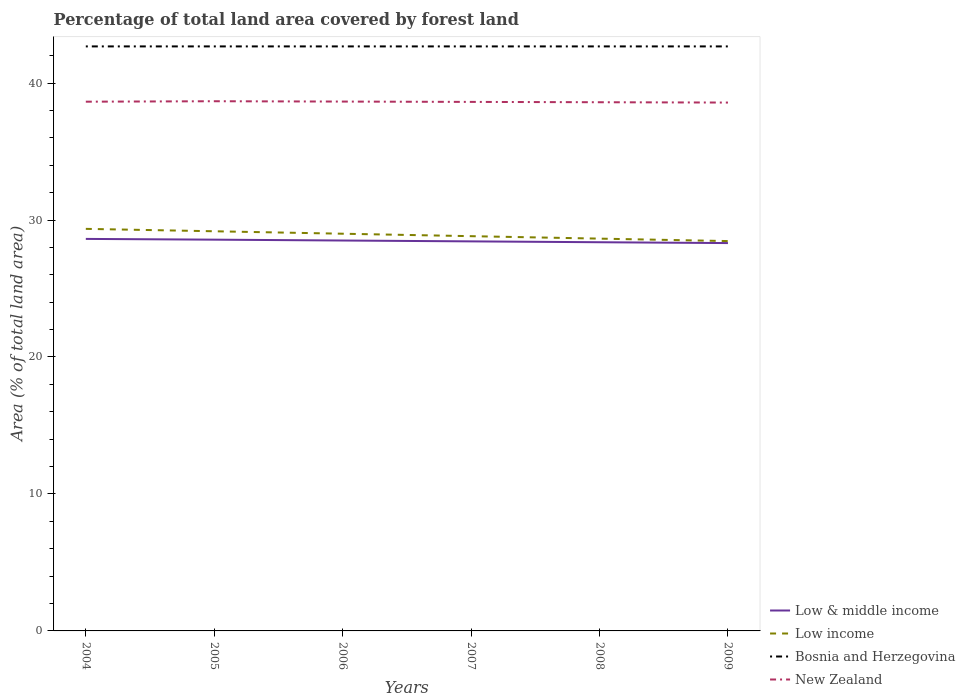How many different coloured lines are there?
Offer a terse response. 4. Is the number of lines equal to the number of legend labels?
Your answer should be very brief. Yes. Across all years, what is the maximum percentage of forest land in Low & middle income?
Ensure brevity in your answer.  28.32. In which year was the percentage of forest land in Bosnia and Herzegovina maximum?
Your response must be concise. 2004. What is the total percentage of forest land in Low & middle income in the graph?
Offer a terse response. 0.06. What is the difference between the highest and the second highest percentage of forest land in Low income?
Give a very brief answer. 0.89. How many lines are there?
Provide a succinct answer. 4. How many years are there in the graph?
Your response must be concise. 6. Are the values on the major ticks of Y-axis written in scientific E-notation?
Your answer should be very brief. No. Where does the legend appear in the graph?
Ensure brevity in your answer.  Bottom right. How many legend labels are there?
Give a very brief answer. 4. How are the legend labels stacked?
Keep it short and to the point. Vertical. What is the title of the graph?
Your answer should be very brief. Percentage of total land area covered by forest land. Does "Finland" appear as one of the legend labels in the graph?
Make the answer very short. No. What is the label or title of the Y-axis?
Provide a short and direct response. Area (% of total land area). What is the Area (% of total land area) in Low & middle income in 2004?
Your answer should be compact. 28.62. What is the Area (% of total land area) of Low income in 2004?
Your answer should be very brief. 29.35. What is the Area (% of total land area) of Bosnia and Herzegovina in 2004?
Your answer should be very brief. 42.68. What is the Area (% of total land area) in New Zealand in 2004?
Offer a very short reply. 38.64. What is the Area (% of total land area) in Low & middle income in 2005?
Keep it short and to the point. 28.57. What is the Area (% of total land area) in Low income in 2005?
Your answer should be very brief. 29.18. What is the Area (% of total land area) of Bosnia and Herzegovina in 2005?
Make the answer very short. 42.68. What is the Area (% of total land area) in New Zealand in 2005?
Offer a very short reply. 38.67. What is the Area (% of total land area) in Low & middle income in 2006?
Your response must be concise. 28.5. What is the Area (% of total land area) in Low income in 2006?
Your answer should be very brief. 29. What is the Area (% of total land area) in Bosnia and Herzegovina in 2006?
Make the answer very short. 42.68. What is the Area (% of total land area) in New Zealand in 2006?
Provide a succinct answer. 38.65. What is the Area (% of total land area) in Low & middle income in 2007?
Your response must be concise. 28.44. What is the Area (% of total land area) of Low income in 2007?
Give a very brief answer. 28.82. What is the Area (% of total land area) in Bosnia and Herzegovina in 2007?
Offer a terse response. 42.68. What is the Area (% of total land area) in New Zealand in 2007?
Offer a terse response. 38.62. What is the Area (% of total land area) in Low & middle income in 2008?
Offer a very short reply. 28.38. What is the Area (% of total land area) of Low income in 2008?
Offer a very short reply. 28.64. What is the Area (% of total land area) in Bosnia and Herzegovina in 2008?
Provide a succinct answer. 42.68. What is the Area (% of total land area) of New Zealand in 2008?
Your response must be concise. 38.6. What is the Area (% of total land area) of Low & middle income in 2009?
Provide a succinct answer. 28.32. What is the Area (% of total land area) in Low income in 2009?
Your response must be concise. 28.46. What is the Area (% of total land area) of Bosnia and Herzegovina in 2009?
Provide a short and direct response. 42.68. What is the Area (% of total land area) in New Zealand in 2009?
Provide a succinct answer. 38.58. Across all years, what is the maximum Area (% of total land area) in Low & middle income?
Your response must be concise. 28.62. Across all years, what is the maximum Area (% of total land area) of Low income?
Give a very brief answer. 29.35. Across all years, what is the maximum Area (% of total land area) of Bosnia and Herzegovina?
Ensure brevity in your answer.  42.68. Across all years, what is the maximum Area (% of total land area) in New Zealand?
Ensure brevity in your answer.  38.67. Across all years, what is the minimum Area (% of total land area) in Low & middle income?
Make the answer very short. 28.32. Across all years, what is the minimum Area (% of total land area) of Low income?
Ensure brevity in your answer.  28.46. Across all years, what is the minimum Area (% of total land area) in Bosnia and Herzegovina?
Keep it short and to the point. 42.68. Across all years, what is the minimum Area (% of total land area) in New Zealand?
Keep it short and to the point. 38.58. What is the total Area (% of total land area) of Low & middle income in the graph?
Give a very brief answer. 170.83. What is the total Area (% of total land area) in Low income in the graph?
Keep it short and to the point. 173.46. What is the total Area (% of total land area) in Bosnia and Herzegovina in the graph?
Make the answer very short. 256.05. What is the total Area (% of total land area) of New Zealand in the graph?
Your answer should be compact. 231.76. What is the difference between the Area (% of total land area) of Low & middle income in 2004 and that in 2005?
Provide a succinct answer. 0.05. What is the difference between the Area (% of total land area) of Low income in 2004 and that in 2005?
Offer a terse response. 0.18. What is the difference between the Area (% of total land area) in Bosnia and Herzegovina in 2004 and that in 2005?
Ensure brevity in your answer.  0. What is the difference between the Area (% of total land area) of New Zealand in 2004 and that in 2005?
Your response must be concise. -0.03. What is the difference between the Area (% of total land area) of Low & middle income in 2004 and that in 2006?
Your answer should be compact. 0.12. What is the difference between the Area (% of total land area) of Low income in 2004 and that in 2006?
Ensure brevity in your answer.  0.35. What is the difference between the Area (% of total land area) in Bosnia and Herzegovina in 2004 and that in 2006?
Your answer should be very brief. 0. What is the difference between the Area (% of total land area) of New Zealand in 2004 and that in 2006?
Provide a short and direct response. -0.01. What is the difference between the Area (% of total land area) in Low & middle income in 2004 and that in 2007?
Keep it short and to the point. 0.18. What is the difference between the Area (% of total land area) in Low income in 2004 and that in 2007?
Keep it short and to the point. 0.53. What is the difference between the Area (% of total land area) of Bosnia and Herzegovina in 2004 and that in 2007?
Offer a very short reply. 0. What is the difference between the Area (% of total land area) in New Zealand in 2004 and that in 2007?
Your answer should be very brief. 0.02. What is the difference between the Area (% of total land area) of Low & middle income in 2004 and that in 2008?
Keep it short and to the point. 0.24. What is the difference between the Area (% of total land area) in Low income in 2004 and that in 2008?
Keep it short and to the point. 0.71. What is the difference between the Area (% of total land area) in Bosnia and Herzegovina in 2004 and that in 2008?
Offer a very short reply. 0. What is the difference between the Area (% of total land area) in New Zealand in 2004 and that in 2008?
Your answer should be compact. 0.04. What is the difference between the Area (% of total land area) of Low & middle income in 2004 and that in 2009?
Ensure brevity in your answer.  0.3. What is the difference between the Area (% of total land area) of Low income in 2004 and that in 2009?
Your response must be concise. 0.89. What is the difference between the Area (% of total land area) of New Zealand in 2004 and that in 2009?
Your answer should be compact. 0.06. What is the difference between the Area (% of total land area) in Low & middle income in 2005 and that in 2006?
Ensure brevity in your answer.  0.06. What is the difference between the Area (% of total land area) in Low income in 2005 and that in 2006?
Offer a very short reply. 0.18. What is the difference between the Area (% of total land area) in Bosnia and Herzegovina in 2005 and that in 2006?
Provide a short and direct response. 0. What is the difference between the Area (% of total land area) in New Zealand in 2005 and that in 2006?
Ensure brevity in your answer.  0.02. What is the difference between the Area (% of total land area) of Low & middle income in 2005 and that in 2007?
Provide a succinct answer. 0.12. What is the difference between the Area (% of total land area) in Low income in 2005 and that in 2007?
Ensure brevity in your answer.  0.36. What is the difference between the Area (% of total land area) of New Zealand in 2005 and that in 2007?
Give a very brief answer. 0.05. What is the difference between the Area (% of total land area) in Low & middle income in 2005 and that in 2008?
Your response must be concise. 0.19. What is the difference between the Area (% of total land area) in Low income in 2005 and that in 2008?
Offer a very short reply. 0.54. What is the difference between the Area (% of total land area) of Bosnia and Herzegovina in 2005 and that in 2008?
Your answer should be very brief. 0. What is the difference between the Area (% of total land area) in New Zealand in 2005 and that in 2008?
Provide a short and direct response. 0.07. What is the difference between the Area (% of total land area) of Low & middle income in 2005 and that in 2009?
Your answer should be compact. 0.25. What is the difference between the Area (% of total land area) of Low income in 2005 and that in 2009?
Keep it short and to the point. 0.72. What is the difference between the Area (% of total land area) of New Zealand in 2005 and that in 2009?
Your answer should be compact. 0.1. What is the difference between the Area (% of total land area) in Low & middle income in 2006 and that in 2007?
Offer a very short reply. 0.06. What is the difference between the Area (% of total land area) of Low income in 2006 and that in 2007?
Offer a terse response. 0.18. What is the difference between the Area (% of total land area) of Bosnia and Herzegovina in 2006 and that in 2007?
Make the answer very short. 0. What is the difference between the Area (% of total land area) in New Zealand in 2006 and that in 2007?
Your answer should be compact. 0.02. What is the difference between the Area (% of total land area) of Low & middle income in 2006 and that in 2008?
Provide a short and direct response. 0.13. What is the difference between the Area (% of total land area) in Low income in 2006 and that in 2008?
Your answer should be very brief. 0.36. What is the difference between the Area (% of total land area) in New Zealand in 2006 and that in 2008?
Your answer should be very brief. 0.05. What is the difference between the Area (% of total land area) of Low & middle income in 2006 and that in 2009?
Offer a very short reply. 0.19. What is the difference between the Area (% of total land area) in Low income in 2006 and that in 2009?
Your answer should be compact. 0.54. What is the difference between the Area (% of total land area) of Bosnia and Herzegovina in 2006 and that in 2009?
Ensure brevity in your answer.  0. What is the difference between the Area (% of total land area) in New Zealand in 2006 and that in 2009?
Your answer should be very brief. 0.07. What is the difference between the Area (% of total land area) in Low & middle income in 2007 and that in 2008?
Your response must be concise. 0.06. What is the difference between the Area (% of total land area) of Low income in 2007 and that in 2008?
Your answer should be very brief. 0.18. What is the difference between the Area (% of total land area) of Bosnia and Herzegovina in 2007 and that in 2008?
Give a very brief answer. 0. What is the difference between the Area (% of total land area) in New Zealand in 2007 and that in 2008?
Your answer should be compact. 0.02. What is the difference between the Area (% of total land area) of Low & middle income in 2007 and that in 2009?
Make the answer very short. 0.12. What is the difference between the Area (% of total land area) in Low income in 2007 and that in 2009?
Ensure brevity in your answer.  0.36. What is the difference between the Area (% of total land area) of Bosnia and Herzegovina in 2007 and that in 2009?
Your answer should be compact. 0. What is the difference between the Area (% of total land area) in New Zealand in 2007 and that in 2009?
Your response must be concise. 0.05. What is the difference between the Area (% of total land area) in Low & middle income in 2008 and that in 2009?
Provide a short and direct response. 0.06. What is the difference between the Area (% of total land area) of Low income in 2008 and that in 2009?
Ensure brevity in your answer.  0.18. What is the difference between the Area (% of total land area) in New Zealand in 2008 and that in 2009?
Your response must be concise. 0.02. What is the difference between the Area (% of total land area) of Low & middle income in 2004 and the Area (% of total land area) of Low income in 2005?
Your response must be concise. -0.56. What is the difference between the Area (% of total land area) in Low & middle income in 2004 and the Area (% of total land area) in Bosnia and Herzegovina in 2005?
Keep it short and to the point. -14.05. What is the difference between the Area (% of total land area) of Low & middle income in 2004 and the Area (% of total land area) of New Zealand in 2005?
Give a very brief answer. -10.05. What is the difference between the Area (% of total land area) in Low income in 2004 and the Area (% of total land area) in Bosnia and Herzegovina in 2005?
Your response must be concise. -13.32. What is the difference between the Area (% of total land area) of Low income in 2004 and the Area (% of total land area) of New Zealand in 2005?
Offer a very short reply. -9.32. What is the difference between the Area (% of total land area) in Bosnia and Herzegovina in 2004 and the Area (% of total land area) in New Zealand in 2005?
Offer a very short reply. 4. What is the difference between the Area (% of total land area) of Low & middle income in 2004 and the Area (% of total land area) of Low income in 2006?
Ensure brevity in your answer.  -0.38. What is the difference between the Area (% of total land area) in Low & middle income in 2004 and the Area (% of total land area) in Bosnia and Herzegovina in 2006?
Provide a succinct answer. -14.05. What is the difference between the Area (% of total land area) of Low & middle income in 2004 and the Area (% of total land area) of New Zealand in 2006?
Make the answer very short. -10.03. What is the difference between the Area (% of total land area) in Low income in 2004 and the Area (% of total land area) in Bosnia and Herzegovina in 2006?
Ensure brevity in your answer.  -13.32. What is the difference between the Area (% of total land area) in Low income in 2004 and the Area (% of total land area) in New Zealand in 2006?
Offer a very short reply. -9.29. What is the difference between the Area (% of total land area) in Bosnia and Herzegovina in 2004 and the Area (% of total land area) in New Zealand in 2006?
Your response must be concise. 4.03. What is the difference between the Area (% of total land area) of Low & middle income in 2004 and the Area (% of total land area) of Low income in 2007?
Offer a very short reply. -0.2. What is the difference between the Area (% of total land area) in Low & middle income in 2004 and the Area (% of total land area) in Bosnia and Herzegovina in 2007?
Give a very brief answer. -14.05. What is the difference between the Area (% of total land area) in Low & middle income in 2004 and the Area (% of total land area) in New Zealand in 2007?
Offer a very short reply. -10. What is the difference between the Area (% of total land area) in Low income in 2004 and the Area (% of total land area) in Bosnia and Herzegovina in 2007?
Make the answer very short. -13.32. What is the difference between the Area (% of total land area) in Low income in 2004 and the Area (% of total land area) in New Zealand in 2007?
Keep it short and to the point. -9.27. What is the difference between the Area (% of total land area) in Bosnia and Herzegovina in 2004 and the Area (% of total land area) in New Zealand in 2007?
Your answer should be compact. 4.05. What is the difference between the Area (% of total land area) of Low & middle income in 2004 and the Area (% of total land area) of Low income in 2008?
Provide a short and direct response. -0.02. What is the difference between the Area (% of total land area) of Low & middle income in 2004 and the Area (% of total land area) of Bosnia and Herzegovina in 2008?
Provide a succinct answer. -14.05. What is the difference between the Area (% of total land area) of Low & middle income in 2004 and the Area (% of total land area) of New Zealand in 2008?
Offer a terse response. -9.98. What is the difference between the Area (% of total land area) of Low income in 2004 and the Area (% of total land area) of Bosnia and Herzegovina in 2008?
Provide a succinct answer. -13.32. What is the difference between the Area (% of total land area) of Low income in 2004 and the Area (% of total land area) of New Zealand in 2008?
Your answer should be compact. -9.25. What is the difference between the Area (% of total land area) in Bosnia and Herzegovina in 2004 and the Area (% of total land area) in New Zealand in 2008?
Keep it short and to the point. 4.08. What is the difference between the Area (% of total land area) of Low & middle income in 2004 and the Area (% of total land area) of Low income in 2009?
Give a very brief answer. 0.16. What is the difference between the Area (% of total land area) in Low & middle income in 2004 and the Area (% of total land area) in Bosnia and Herzegovina in 2009?
Offer a very short reply. -14.05. What is the difference between the Area (% of total land area) of Low & middle income in 2004 and the Area (% of total land area) of New Zealand in 2009?
Offer a terse response. -9.95. What is the difference between the Area (% of total land area) of Low income in 2004 and the Area (% of total land area) of Bosnia and Herzegovina in 2009?
Offer a terse response. -13.32. What is the difference between the Area (% of total land area) in Low income in 2004 and the Area (% of total land area) in New Zealand in 2009?
Keep it short and to the point. -9.22. What is the difference between the Area (% of total land area) of Bosnia and Herzegovina in 2004 and the Area (% of total land area) of New Zealand in 2009?
Provide a succinct answer. 4.1. What is the difference between the Area (% of total land area) in Low & middle income in 2005 and the Area (% of total land area) in Low income in 2006?
Your response must be concise. -0.43. What is the difference between the Area (% of total land area) in Low & middle income in 2005 and the Area (% of total land area) in Bosnia and Herzegovina in 2006?
Ensure brevity in your answer.  -14.11. What is the difference between the Area (% of total land area) of Low & middle income in 2005 and the Area (% of total land area) of New Zealand in 2006?
Keep it short and to the point. -10.08. What is the difference between the Area (% of total land area) in Low income in 2005 and the Area (% of total land area) in Bosnia and Herzegovina in 2006?
Provide a succinct answer. -13.5. What is the difference between the Area (% of total land area) in Low income in 2005 and the Area (% of total land area) in New Zealand in 2006?
Your answer should be compact. -9.47. What is the difference between the Area (% of total land area) in Bosnia and Herzegovina in 2005 and the Area (% of total land area) in New Zealand in 2006?
Give a very brief answer. 4.03. What is the difference between the Area (% of total land area) in Low & middle income in 2005 and the Area (% of total land area) in Low income in 2007?
Provide a succinct answer. -0.25. What is the difference between the Area (% of total land area) of Low & middle income in 2005 and the Area (% of total land area) of Bosnia and Herzegovina in 2007?
Your answer should be very brief. -14.11. What is the difference between the Area (% of total land area) in Low & middle income in 2005 and the Area (% of total land area) in New Zealand in 2007?
Provide a succinct answer. -10.06. What is the difference between the Area (% of total land area) in Low income in 2005 and the Area (% of total land area) in Bosnia and Herzegovina in 2007?
Provide a short and direct response. -13.5. What is the difference between the Area (% of total land area) of Low income in 2005 and the Area (% of total land area) of New Zealand in 2007?
Your answer should be compact. -9.45. What is the difference between the Area (% of total land area) of Bosnia and Herzegovina in 2005 and the Area (% of total land area) of New Zealand in 2007?
Provide a short and direct response. 4.05. What is the difference between the Area (% of total land area) of Low & middle income in 2005 and the Area (% of total land area) of Low income in 2008?
Make the answer very short. -0.08. What is the difference between the Area (% of total land area) in Low & middle income in 2005 and the Area (% of total land area) in Bosnia and Herzegovina in 2008?
Your response must be concise. -14.11. What is the difference between the Area (% of total land area) of Low & middle income in 2005 and the Area (% of total land area) of New Zealand in 2008?
Keep it short and to the point. -10.03. What is the difference between the Area (% of total land area) of Low income in 2005 and the Area (% of total land area) of Bosnia and Herzegovina in 2008?
Provide a short and direct response. -13.5. What is the difference between the Area (% of total land area) of Low income in 2005 and the Area (% of total land area) of New Zealand in 2008?
Give a very brief answer. -9.42. What is the difference between the Area (% of total land area) in Bosnia and Herzegovina in 2005 and the Area (% of total land area) in New Zealand in 2008?
Give a very brief answer. 4.08. What is the difference between the Area (% of total land area) of Low & middle income in 2005 and the Area (% of total land area) of Low income in 2009?
Make the answer very short. 0.1. What is the difference between the Area (% of total land area) of Low & middle income in 2005 and the Area (% of total land area) of Bosnia and Herzegovina in 2009?
Offer a very short reply. -14.11. What is the difference between the Area (% of total land area) of Low & middle income in 2005 and the Area (% of total land area) of New Zealand in 2009?
Ensure brevity in your answer.  -10.01. What is the difference between the Area (% of total land area) in Low income in 2005 and the Area (% of total land area) in Bosnia and Herzegovina in 2009?
Offer a terse response. -13.5. What is the difference between the Area (% of total land area) of Low income in 2005 and the Area (% of total land area) of New Zealand in 2009?
Ensure brevity in your answer.  -9.4. What is the difference between the Area (% of total land area) of Bosnia and Herzegovina in 2005 and the Area (% of total land area) of New Zealand in 2009?
Keep it short and to the point. 4.1. What is the difference between the Area (% of total land area) of Low & middle income in 2006 and the Area (% of total land area) of Low income in 2007?
Offer a terse response. -0.32. What is the difference between the Area (% of total land area) of Low & middle income in 2006 and the Area (% of total land area) of Bosnia and Herzegovina in 2007?
Offer a terse response. -14.17. What is the difference between the Area (% of total land area) in Low & middle income in 2006 and the Area (% of total land area) in New Zealand in 2007?
Your answer should be compact. -10.12. What is the difference between the Area (% of total land area) in Low income in 2006 and the Area (% of total land area) in Bosnia and Herzegovina in 2007?
Keep it short and to the point. -13.68. What is the difference between the Area (% of total land area) in Low income in 2006 and the Area (% of total land area) in New Zealand in 2007?
Offer a terse response. -9.62. What is the difference between the Area (% of total land area) of Bosnia and Herzegovina in 2006 and the Area (% of total land area) of New Zealand in 2007?
Offer a very short reply. 4.05. What is the difference between the Area (% of total land area) of Low & middle income in 2006 and the Area (% of total land area) of Low income in 2008?
Your answer should be very brief. -0.14. What is the difference between the Area (% of total land area) in Low & middle income in 2006 and the Area (% of total land area) in Bosnia and Herzegovina in 2008?
Provide a short and direct response. -14.17. What is the difference between the Area (% of total land area) of Low & middle income in 2006 and the Area (% of total land area) of New Zealand in 2008?
Give a very brief answer. -10.1. What is the difference between the Area (% of total land area) in Low income in 2006 and the Area (% of total land area) in Bosnia and Herzegovina in 2008?
Your answer should be compact. -13.68. What is the difference between the Area (% of total land area) in Low income in 2006 and the Area (% of total land area) in New Zealand in 2008?
Your answer should be very brief. -9.6. What is the difference between the Area (% of total land area) in Bosnia and Herzegovina in 2006 and the Area (% of total land area) in New Zealand in 2008?
Offer a very short reply. 4.08. What is the difference between the Area (% of total land area) in Low & middle income in 2006 and the Area (% of total land area) in Low income in 2009?
Your answer should be very brief. 0.04. What is the difference between the Area (% of total land area) of Low & middle income in 2006 and the Area (% of total land area) of Bosnia and Herzegovina in 2009?
Offer a terse response. -14.17. What is the difference between the Area (% of total land area) of Low & middle income in 2006 and the Area (% of total land area) of New Zealand in 2009?
Keep it short and to the point. -10.07. What is the difference between the Area (% of total land area) of Low income in 2006 and the Area (% of total land area) of Bosnia and Herzegovina in 2009?
Offer a terse response. -13.68. What is the difference between the Area (% of total land area) in Low income in 2006 and the Area (% of total land area) in New Zealand in 2009?
Your answer should be compact. -9.58. What is the difference between the Area (% of total land area) of Bosnia and Herzegovina in 2006 and the Area (% of total land area) of New Zealand in 2009?
Your response must be concise. 4.1. What is the difference between the Area (% of total land area) of Low & middle income in 2007 and the Area (% of total land area) of Low income in 2008?
Offer a terse response. -0.2. What is the difference between the Area (% of total land area) of Low & middle income in 2007 and the Area (% of total land area) of Bosnia and Herzegovina in 2008?
Your answer should be very brief. -14.23. What is the difference between the Area (% of total land area) of Low & middle income in 2007 and the Area (% of total land area) of New Zealand in 2008?
Your response must be concise. -10.16. What is the difference between the Area (% of total land area) of Low income in 2007 and the Area (% of total land area) of Bosnia and Herzegovina in 2008?
Your answer should be compact. -13.85. What is the difference between the Area (% of total land area) in Low income in 2007 and the Area (% of total land area) in New Zealand in 2008?
Keep it short and to the point. -9.78. What is the difference between the Area (% of total land area) in Bosnia and Herzegovina in 2007 and the Area (% of total land area) in New Zealand in 2008?
Your response must be concise. 4.08. What is the difference between the Area (% of total land area) in Low & middle income in 2007 and the Area (% of total land area) in Low income in 2009?
Ensure brevity in your answer.  -0.02. What is the difference between the Area (% of total land area) of Low & middle income in 2007 and the Area (% of total land area) of Bosnia and Herzegovina in 2009?
Offer a terse response. -14.23. What is the difference between the Area (% of total land area) of Low & middle income in 2007 and the Area (% of total land area) of New Zealand in 2009?
Offer a terse response. -10.13. What is the difference between the Area (% of total land area) in Low income in 2007 and the Area (% of total land area) in Bosnia and Herzegovina in 2009?
Make the answer very short. -13.85. What is the difference between the Area (% of total land area) in Low income in 2007 and the Area (% of total land area) in New Zealand in 2009?
Offer a terse response. -9.75. What is the difference between the Area (% of total land area) in Bosnia and Herzegovina in 2007 and the Area (% of total land area) in New Zealand in 2009?
Give a very brief answer. 4.1. What is the difference between the Area (% of total land area) of Low & middle income in 2008 and the Area (% of total land area) of Low income in 2009?
Provide a short and direct response. -0.08. What is the difference between the Area (% of total land area) in Low & middle income in 2008 and the Area (% of total land area) in Bosnia and Herzegovina in 2009?
Offer a very short reply. -14.3. What is the difference between the Area (% of total land area) in Low & middle income in 2008 and the Area (% of total land area) in New Zealand in 2009?
Offer a terse response. -10.2. What is the difference between the Area (% of total land area) of Low income in 2008 and the Area (% of total land area) of Bosnia and Herzegovina in 2009?
Make the answer very short. -14.03. What is the difference between the Area (% of total land area) of Low income in 2008 and the Area (% of total land area) of New Zealand in 2009?
Provide a short and direct response. -9.93. What is the difference between the Area (% of total land area) of Bosnia and Herzegovina in 2008 and the Area (% of total land area) of New Zealand in 2009?
Provide a succinct answer. 4.1. What is the average Area (% of total land area) of Low & middle income per year?
Your response must be concise. 28.47. What is the average Area (% of total land area) in Low income per year?
Offer a very short reply. 28.91. What is the average Area (% of total land area) in Bosnia and Herzegovina per year?
Your answer should be very brief. 42.68. What is the average Area (% of total land area) in New Zealand per year?
Your response must be concise. 38.63. In the year 2004, what is the difference between the Area (% of total land area) in Low & middle income and Area (% of total land area) in Low income?
Give a very brief answer. -0.73. In the year 2004, what is the difference between the Area (% of total land area) in Low & middle income and Area (% of total land area) in Bosnia and Herzegovina?
Make the answer very short. -14.05. In the year 2004, what is the difference between the Area (% of total land area) in Low & middle income and Area (% of total land area) in New Zealand?
Offer a terse response. -10.02. In the year 2004, what is the difference between the Area (% of total land area) in Low income and Area (% of total land area) in Bosnia and Herzegovina?
Ensure brevity in your answer.  -13.32. In the year 2004, what is the difference between the Area (% of total land area) of Low income and Area (% of total land area) of New Zealand?
Your answer should be compact. -9.28. In the year 2004, what is the difference between the Area (% of total land area) in Bosnia and Herzegovina and Area (% of total land area) in New Zealand?
Keep it short and to the point. 4.04. In the year 2005, what is the difference between the Area (% of total land area) of Low & middle income and Area (% of total land area) of Low income?
Keep it short and to the point. -0.61. In the year 2005, what is the difference between the Area (% of total land area) in Low & middle income and Area (% of total land area) in Bosnia and Herzegovina?
Your response must be concise. -14.11. In the year 2005, what is the difference between the Area (% of total land area) of Low & middle income and Area (% of total land area) of New Zealand?
Provide a short and direct response. -10.11. In the year 2005, what is the difference between the Area (% of total land area) of Low income and Area (% of total land area) of Bosnia and Herzegovina?
Keep it short and to the point. -13.5. In the year 2005, what is the difference between the Area (% of total land area) in Low income and Area (% of total land area) in New Zealand?
Your response must be concise. -9.49. In the year 2005, what is the difference between the Area (% of total land area) in Bosnia and Herzegovina and Area (% of total land area) in New Zealand?
Offer a very short reply. 4. In the year 2006, what is the difference between the Area (% of total land area) of Low & middle income and Area (% of total land area) of Low income?
Ensure brevity in your answer.  -0.5. In the year 2006, what is the difference between the Area (% of total land area) in Low & middle income and Area (% of total land area) in Bosnia and Herzegovina?
Give a very brief answer. -14.17. In the year 2006, what is the difference between the Area (% of total land area) in Low & middle income and Area (% of total land area) in New Zealand?
Ensure brevity in your answer.  -10.14. In the year 2006, what is the difference between the Area (% of total land area) of Low income and Area (% of total land area) of Bosnia and Herzegovina?
Offer a terse response. -13.68. In the year 2006, what is the difference between the Area (% of total land area) of Low income and Area (% of total land area) of New Zealand?
Provide a succinct answer. -9.65. In the year 2006, what is the difference between the Area (% of total land area) of Bosnia and Herzegovina and Area (% of total land area) of New Zealand?
Offer a very short reply. 4.03. In the year 2007, what is the difference between the Area (% of total land area) of Low & middle income and Area (% of total land area) of Low income?
Offer a terse response. -0.38. In the year 2007, what is the difference between the Area (% of total land area) in Low & middle income and Area (% of total land area) in Bosnia and Herzegovina?
Give a very brief answer. -14.23. In the year 2007, what is the difference between the Area (% of total land area) in Low & middle income and Area (% of total land area) in New Zealand?
Your response must be concise. -10.18. In the year 2007, what is the difference between the Area (% of total land area) of Low income and Area (% of total land area) of Bosnia and Herzegovina?
Provide a succinct answer. -13.85. In the year 2007, what is the difference between the Area (% of total land area) in Low income and Area (% of total land area) in New Zealand?
Offer a very short reply. -9.8. In the year 2007, what is the difference between the Area (% of total land area) of Bosnia and Herzegovina and Area (% of total land area) of New Zealand?
Keep it short and to the point. 4.05. In the year 2008, what is the difference between the Area (% of total land area) in Low & middle income and Area (% of total land area) in Low income?
Your response must be concise. -0.26. In the year 2008, what is the difference between the Area (% of total land area) of Low & middle income and Area (% of total land area) of Bosnia and Herzegovina?
Your response must be concise. -14.3. In the year 2008, what is the difference between the Area (% of total land area) in Low & middle income and Area (% of total land area) in New Zealand?
Keep it short and to the point. -10.22. In the year 2008, what is the difference between the Area (% of total land area) in Low income and Area (% of total land area) in Bosnia and Herzegovina?
Offer a terse response. -14.03. In the year 2008, what is the difference between the Area (% of total land area) of Low income and Area (% of total land area) of New Zealand?
Provide a succinct answer. -9.96. In the year 2008, what is the difference between the Area (% of total land area) of Bosnia and Herzegovina and Area (% of total land area) of New Zealand?
Provide a succinct answer. 4.08. In the year 2009, what is the difference between the Area (% of total land area) in Low & middle income and Area (% of total land area) in Low income?
Offer a terse response. -0.15. In the year 2009, what is the difference between the Area (% of total land area) in Low & middle income and Area (% of total land area) in Bosnia and Herzegovina?
Your answer should be very brief. -14.36. In the year 2009, what is the difference between the Area (% of total land area) in Low & middle income and Area (% of total land area) in New Zealand?
Make the answer very short. -10.26. In the year 2009, what is the difference between the Area (% of total land area) in Low income and Area (% of total land area) in Bosnia and Herzegovina?
Provide a short and direct response. -14.21. In the year 2009, what is the difference between the Area (% of total land area) of Low income and Area (% of total land area) of New Zealand?
Your response must be concise. -10.11. What is the ratio of the Area (% of total land area) of New Zealand in 2004 to that in 2005?
Make the answer very short. 1. What is the ratio of the Area (% of total land area) of Low & middle income in 2004 to that in 2006?
Keep it short and to the point. 1. What is the ratio of the Area (% of total land area) in Low income in 2004 to that in 2006?
Offer a terse response. 1.01. What is the ratio of the Area (% of total land area) of Bosnia and Herzegovina in 2004 to that in 2006?
Your answer should be compact. 1. What is the ratio of the Area (% of total land area) of New Zealand in 2004 to that in 2006?
Offer a very short reply. 1. What is the ratio of the Area (% of total land area) of Low income in 2004 to that in 2007?
Keep it short and to the point. 1.02. What is the ratio of the Area (% of total land area) of Bosnia and Herzegovina in 2004 to that in 2007?
Make the answer very short. 1. What is the ratio of the Area (% of total land area) of Low & middle income in 2004 to that in 2008?
Your answer should be very brief. 1.01. What is the ratio of the Area (% of total land area) in Low income in 2004 to that in 2008?
Provide a succinct answer. 1.02. What is the ratio of the Area (% of total land area) of Low & middle income in 2004 to that in 2009?
Your answer should be compact. 1.01. What is the ratio of the Area (% of total land area) of Low income in 2004 to that in 2009?
Offer a terse response. 1.03. What is the ratio of the Area (% of total land area) of Bosnia and Herzegovina in 2004 to that in 2009?
Provide a short and direct response. 1. What is the ratio of the Area (% of total land area) of New Zealand in 2004 to that in 2009?
Give a very brief answer. 1. What is the ratio of the Area (% of total land area) of Low income in 2005 to that in 2006?
Your response must be concise. 1.01. What is the ratio of the Area (% of total land area) in New Zealand in 2005 to that in 2006?
Your response must be concise. 1. What is the ratio of the Area (% of total land area) in Low income in 2005 to that in 2007?
Your response must be concise. 1.01. What is the ratio of the Area (% of total land area) in Bosnia and Herzegovina in 2005 to that in 2007?
Your answer should be very brief. 1. What is the ratio of the Area (% of total land area) in New Zealand in 2005 to that in 2007?
Keep it short and to the point. 1. What is the ratio of the Area (% of total land area) in Low & middle income in 2005 to that in 2008?
Offer a very short reply. 1.01. What is the ratio of the Area (% of total land area) in Low income in 2005 to that in 2008?
Offer a very short reply. 1.02. What is the ratio of the Area (% of total land area) of Low & middle income in 2005 to that in 2009?
Give a very brief answer. 1.01. What is the ratio of the Area (% of total land area) in Low income in 2005 to that in 2009?
Make the answer very short. 1.03. What is the ratio of the Area (% of total land area) in Low & middle income in 2006 to that in 2007?
Your response must be concise. 1. What is the ratio of the Area (% of total land area) in Bosnia and Herzegovina in 2006 to that in 2007?
Provide a short and direct response. 1. What is the ratio of the Area (% of total land area) in New Zealand in 2006 to that in 2007?
Offer a terse response. 1. What is the ratio of the Area (% of total land area) of Low income in 2006 to that in 2008?
Make the answer very short. 1.01. What is the ratio of the Area (% of total land area) in Low & middle income in 2006 to that in 2009?
Give a very brief answer. 1.01. What is the ratio of the Area (% of total land area) of Low income in 2006 to that in 2009?
Provide a short and direct response. 1.02. What is the ratio of the Area (% of total land area) in Low & middle income in 2007 to that in 2008?
Ensure brevity in your answer.  1. What is the ratio of the Area (% of total land area) in Low income in 2007 to that in 2008?
Make the answer very short. 1.01. What is the ratio of the Area (% of total land area) of Low income in 2007 to that in 2009?
Your answer should be very brief. 1.01. What is the ratio of the Area (% of total land area) in New Zealand in 2007 to that in 2009?
Ensure brevity in your answer.  1. What is the ratio of the Area (% of total land area) of Low & middle income in 2008 to that in 2009?
Your answer should be very brief. 1. What is the ratio of the Area (% of total land area) of Low income in 2008 to that in 2009?
Your response must be concise. 1.01. What is the ratio of the Area (% of total land area) in Bosnia and Herzegovina in 2008 to that in 2009?
Ensure brevity in your answer.  1. What is the difference between the highest and the second highest Area (% of total land area) of Low & middle income?
Provide a short and direct response. 0.05. What is the difference between the highest and the second highest Area (% of total land area) in Low income?
Offer a very short reply. 0.18. What is the difference between the highest and the second highest Area (% of total land area) of Bosnia and Herzegovina?
Offer a terse response. 0. What is the difference between the highest and the second highest Area (% of total land area) of New Zealand?
Offer a very short reply. 0.02. What is the difference between the highest and the lowest Area (% of total land area) in Low & middle income?
Your answer should be compact. 0.3. What is the difference between the highest and the lowest Area (% of total land area) in Low income?
Your response must be concise. 0.89. What is the difference between the highest and the lowest Area (% of total land area) of New Zealand?
Make the answer very short. 0.1. 